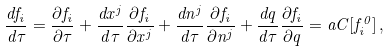<formula> <loc_0><loc_0><loc_500><loc_500>\frac { d f _ { i } } { d \tau } = \frac { \partial f _ { i } } { \partial \tau } + \frac { d x ^ { j } } { d \tau } \frac { \partial f _ { i } } { \partial x ^ { j } } + \frac { d n ^ { j } } { d \tau } \frac { \partial f _ { i } } { \partial n ^ { j } } + \frac { d q } { d \tau } \frac { \partial f _ { i } } { \partial q } = a C [ f _ { i } ^ { 0 } ] \, ,</formula> 